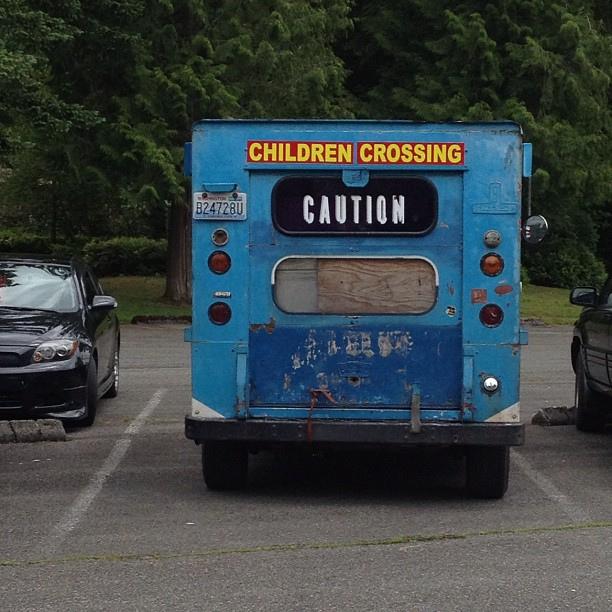Where is the license plate located?
Keep it brief. Top left. Why is this truck stopped?
Write a very short answer. Parked. What language is that?
Concise answer only. English. Who is riding the bus?
Short answer required. Children. What age group does this vehicle serve?
Be succinct. Children. How many arrows do you see in this picture?
Answer briefly. 0. 